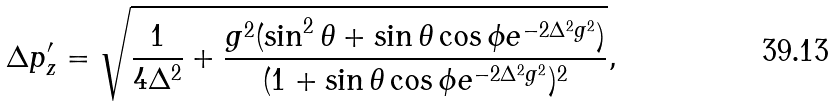<formula> <loc_0><loc_0><loc_500><loc_500>\Delta p _ { z } ^ { \prime } = \sqrt { \frac { 1 } { 4 \Delta ^ { 2 } } + \frac { g ^ { 2 } ( \sin ^ { 2 } { \theta } + \sin { \theta } \cos { \phi } e ^ { - 2 \Delta ^ { 2 } g ^ { 2 } } ) } { ( 1 + \sin { \theta } \cos { \phi } e ^ { - 2 \Delta ^ { 2 } g ^ { 2 } } ) ^ { 2 } } } ,</formula> 